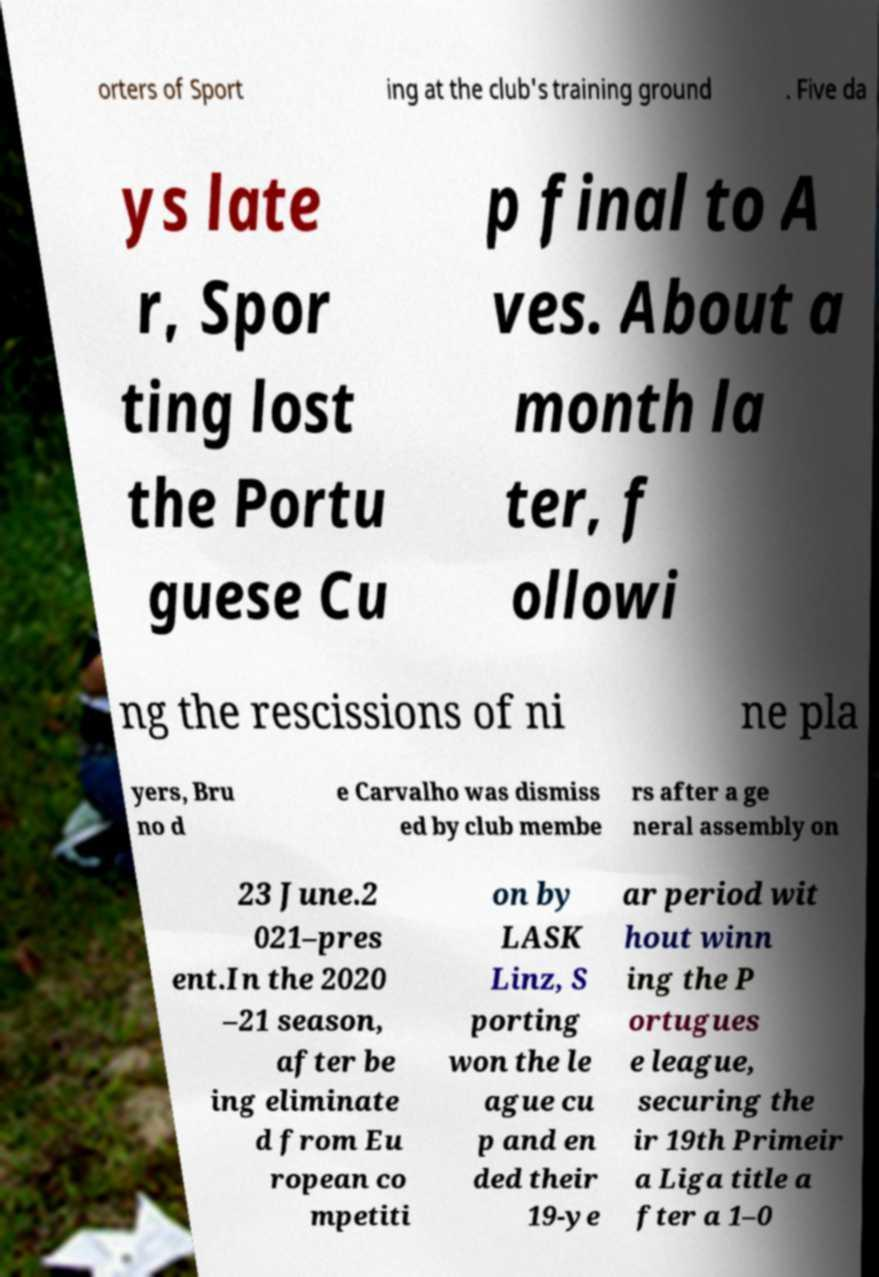Could you assist in decoding the text presented in this image and type it out clearly? orters of Sport ing at the club's training ground . Five da ys late r, Spor ting lost the Portu guese Cu p final to A ves. About a month la ter, f ollowi ng the rescissions of ni ne pla yers, Bru no d e Carvalho was dismiss ed by club membe rs after a ge neral assembly on 23 June.2 021–pres ent.In the 2020 –21 season, after be ing eliminate d from Eu ropean co mpetiti on by LASK Linz, S porting won the le ague cu p and en ded their 19-ye ar period wit hout winn ing the P ortugues e league, securing the ir 19th Primeir a Liga title a fter a 1–0 